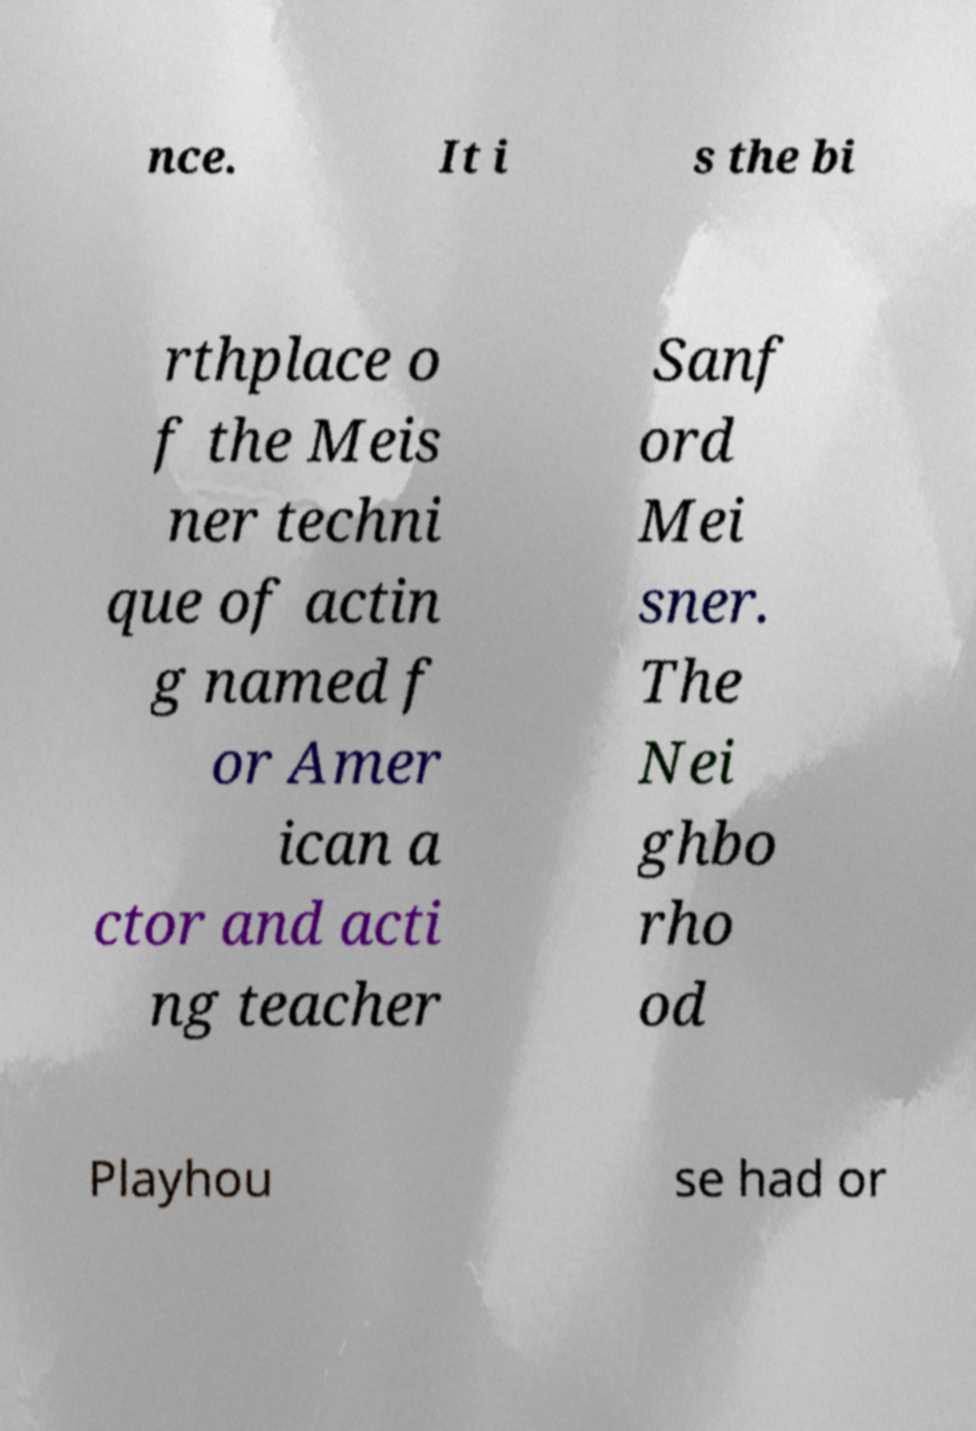What messages or text are displayed in this image? I need them in a readable, typed format. nce. It i s the bi rthplace o f the Meis ner techni que of actin g named f or Amer ican a ctor and acti ng teacher Sanf ord Mei sner. The Nei ghbo rho od Playhou se had or 